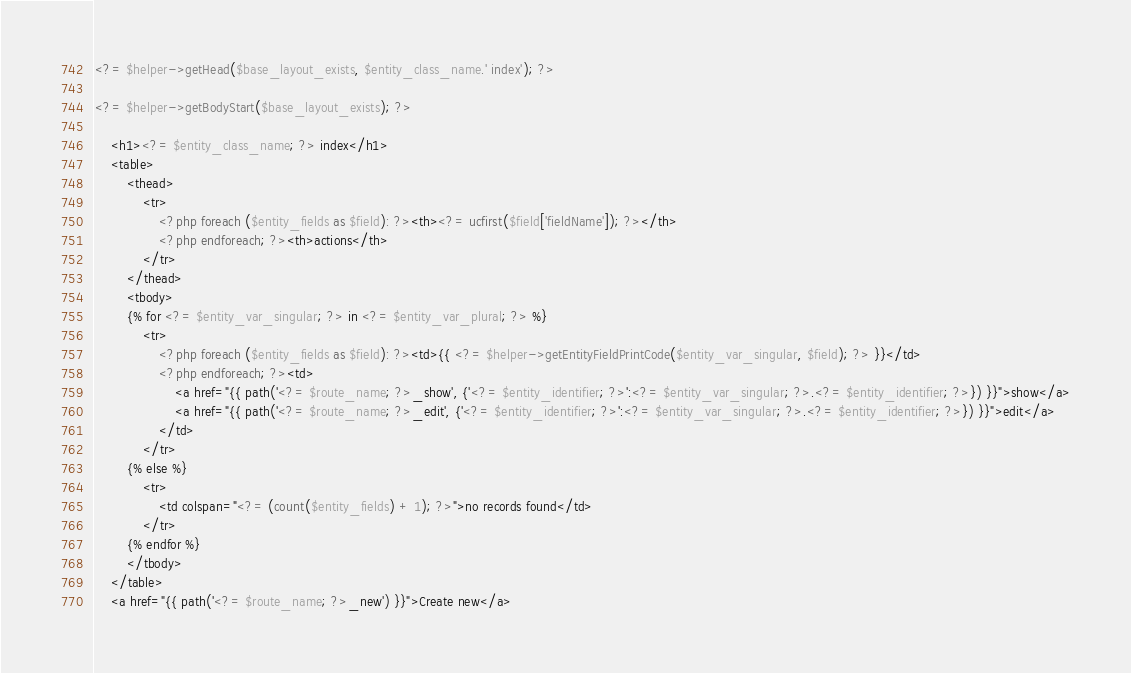<code> <loc_0><loc_0><loc_500><loc_500><_PHP_><?= $helper->getHead($base_layout_exists, $entity_class_name.' index'); ?>

<?= $helper->getBodyStart($base_layout_exists); ?>

    <h1><?= $entity_class_name; ?> index</h1>
    <table>
        <thead>
            <tr>
                <?php foreach ($entity_fields as $field): ?><th><?= ucfirst($field['fieldName']); ?></th>
                <?php endforeach; ?><th>actions</th>
            </tr>
        </thead>
        <tbody>
        {% for <?= $entity_var_singular; ?> in <?= $entity_var_plural; ?> %}
            <tr>
                <?php foreach ($entity_fields as $field): ?><td>{{ <?= $helper->getEntityFieldPrintCode($entity_var_singular, $field); ?> }}</td>
                <?php endforeach; ?><td>
                    <a href="{{ path('<?= $route_name; ?>_show', {'<?= $entity_identifier; ?>':<?= $entity_var_singular; ?>.<?= $entity_identifier; ?>}) }}">show</a>
                    <a href="{{ path('<?= $route_name; ?>_edit', {'<?= $entity_identifier; ?>':<?= $entity_var_singular; ?>.<?= $entity_identifier; ?>}) }}">edit</a>
                </td>
            </tr>
        {% else %}
            <tr>
                <td colspan="<?= (count($entity_fields) + 1); ?>">no records found</td>
            </tr>
        {% endfor %}
        </tbody>
    </table>
    <a href="{{ path('<?= $route_name; ?>_new') }}">Create new</a>
</code> 